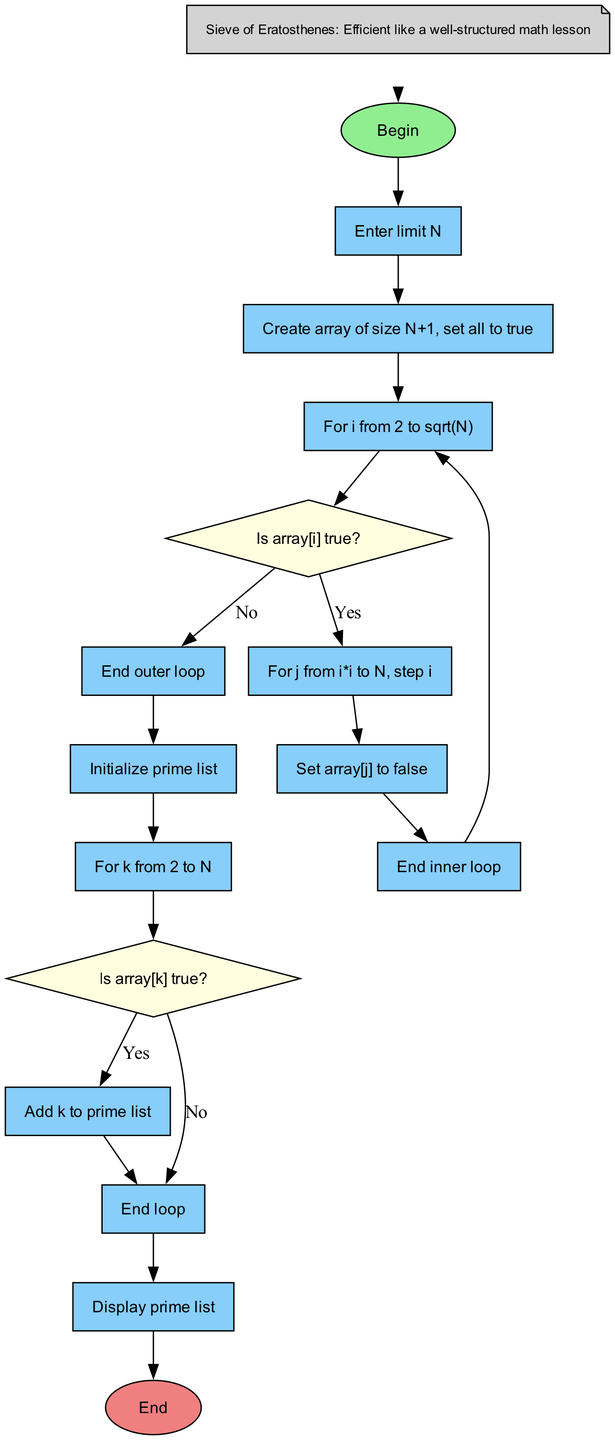What is the first step in the algorithm? The first step is labeled as "Begin" and it indicates the start of the flowchart.
Answer: Begin How many main loops are present in the diagram? There are three main loops: loop1, loop2, and loop3. Each is part of the process for determining prime numbers.
Answer: 3 What does the condition 'Is array[i] true?' check? This condition checks whether the current number at index i is still marked as prime in the boolean array.
Answer: array[i] true What happens when 'Is array[k] true?' is false? If this condition is false, the flow control goes to 'end_loop3,' skipping the step to add k to the prime list.
Answer: End loop Which step follows the initialization of the prime list? The step that follows is 'For k from 2 to N,' where the algorithm begins checking each number for primality.
Answer: For k from 2 to N After marking 'array[j] = false,' what is the next action? The next action is to return to 'end_loop2,' concluding the inner loop that was marking non-prime numbers.
Answer: End inner loop What is the purpose of the note included in the diagram? The note provides context that relates the algorithm to a teaching method, indicating its efficiency similar to an organized math lesson.
Answer: Efficient like a well-structured math lesson What does the program output after processing? The program outputs a list of prime numbers generated up to the specified limit N.
Answer: prime list 